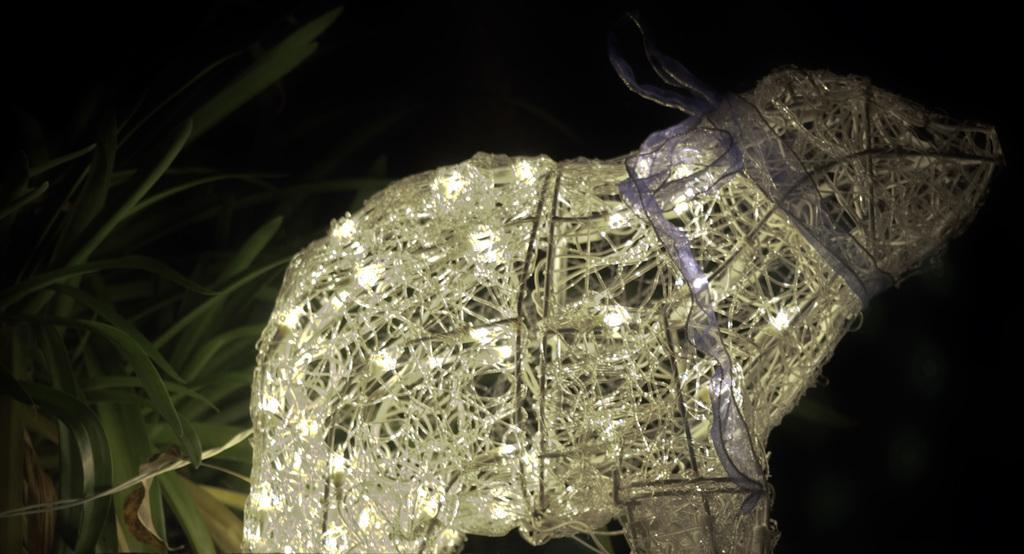What type of decoration can be seen in the image? There are lights as decoration in the image. What color are the leaves in the image? The leaves in the image are green. How would you describe the lighting in the image? The image appears to be slightly dark in the background. How many cabbages are visible in the image? There are no cabbages present in the image. What type of test is being conducted in the image? There is no test being conducted in the image. 